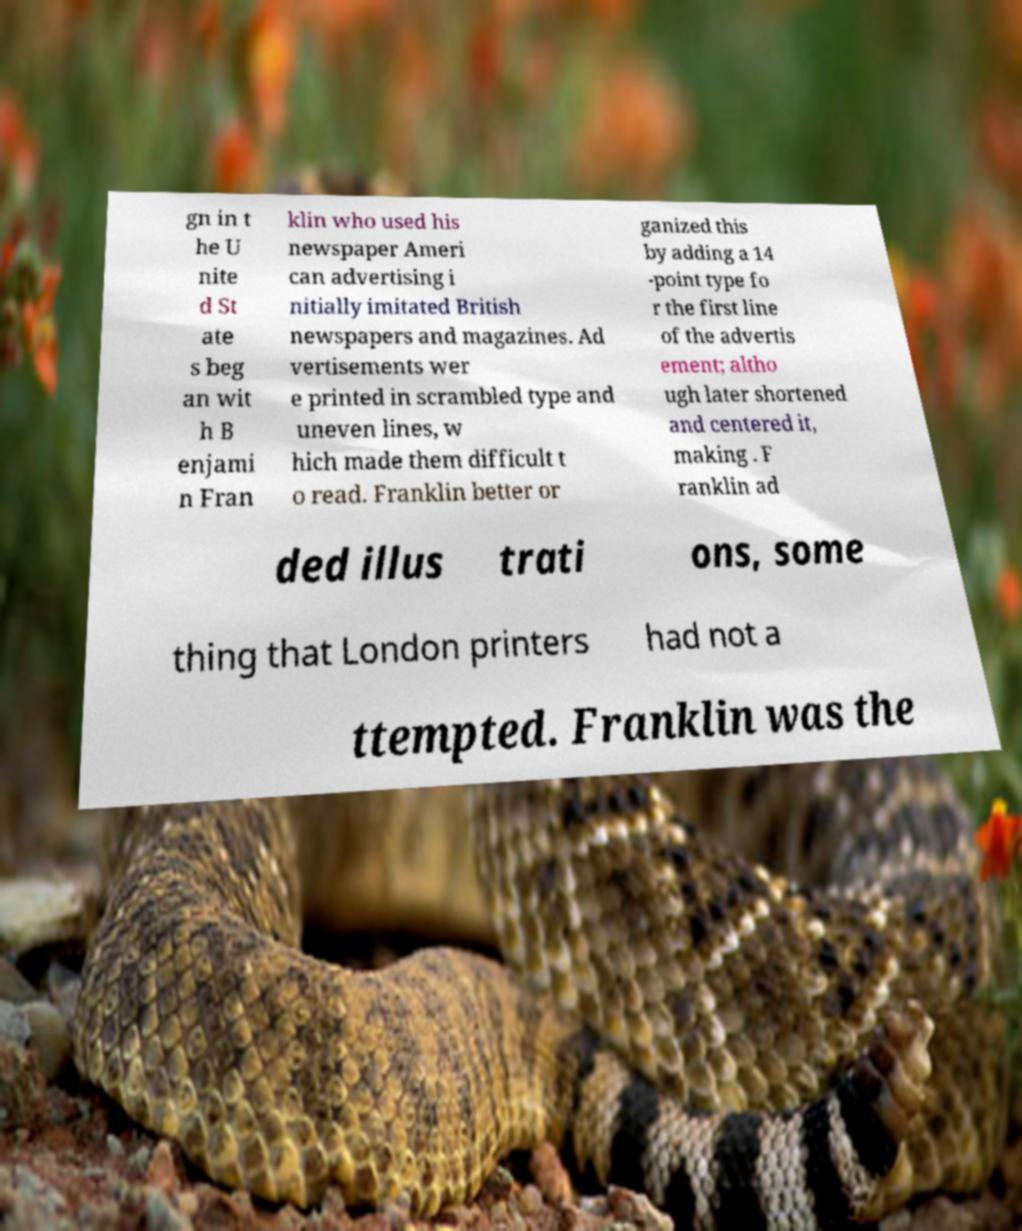Could you assist in decoding the text presented in this image and type it out clearly? gn in t he U nite d St ate s beg an wit h B enjami n Fran klin who used his newspaper Ameri can advertising i nitially imitated British newspapers and magazines. Ad vertisements wer e printed in scrambled type and uneven lines, w hich made them difficult t o read. Franklin better or ganized this by adding a 14 -point type fo r the first line of the advertis ement; altho ugh later shortened and centered it, making . F ranklin ad ded illus trati ons, some thing that London printers had not a ttempted. Franklin was the 